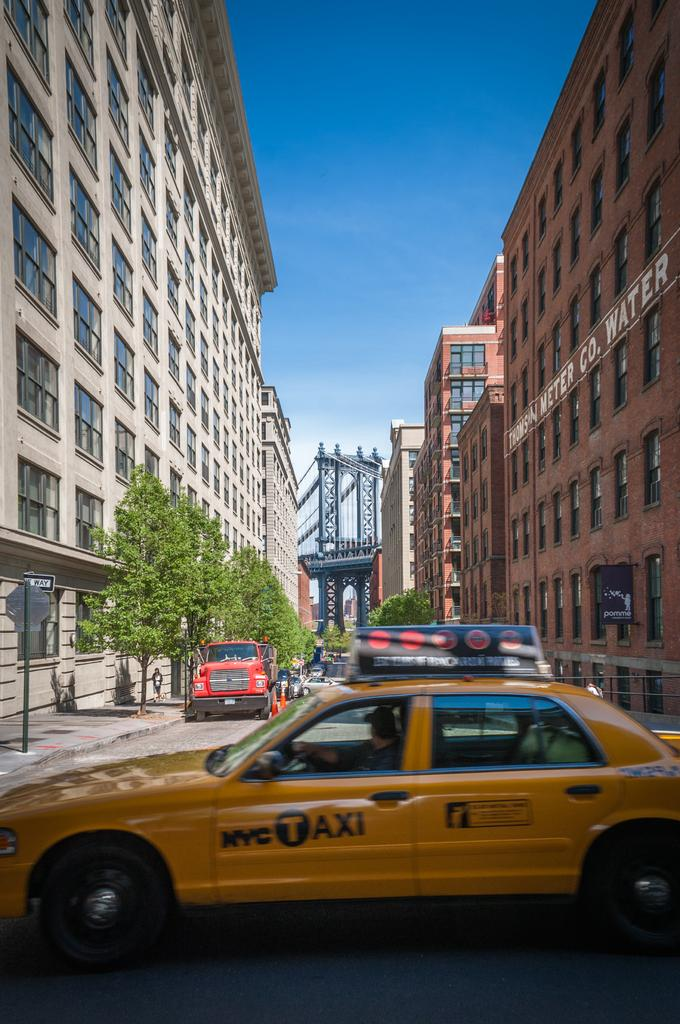Provide a one-sentence caption for the provided image. A taxi with the NYC Taxi logo drives by a street with a bridge in the background. 